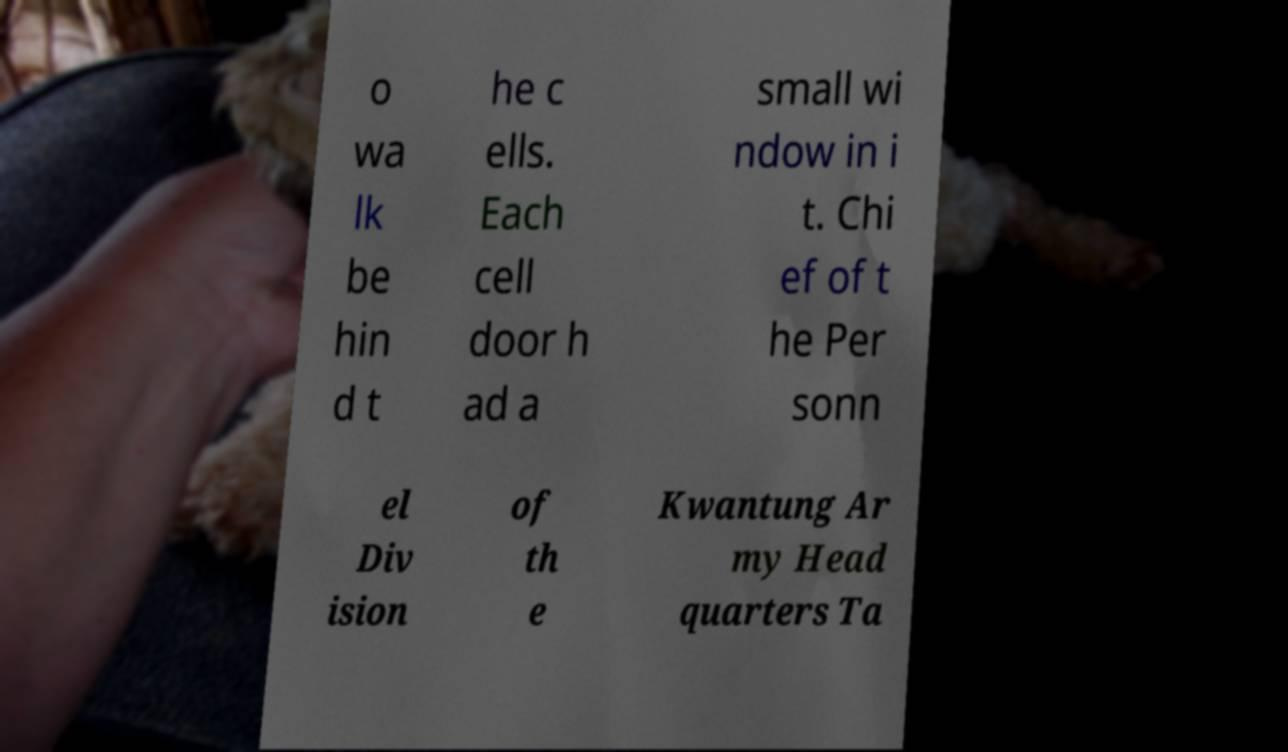Please identify and transcribe the text found in this image. o wa lk be hin d t he c ells. Each cell door h ad a small wi ndow in i t. Chi ef of t he Per sonn el Div ision of th e Kwantung Ar my Head quarters Ta 